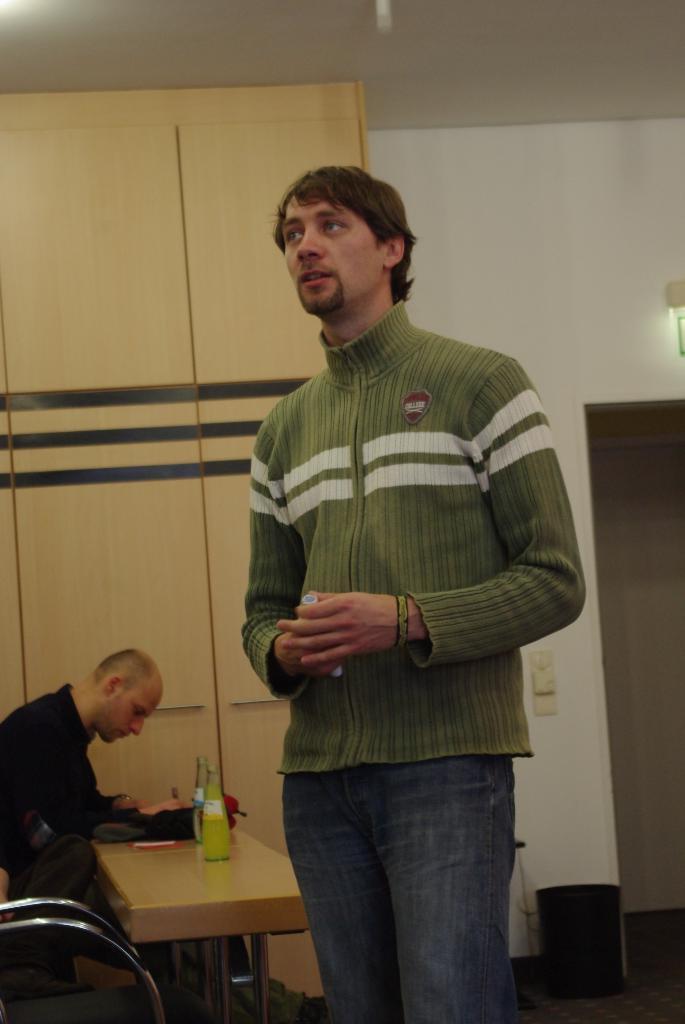Can you describe this image briefly? This is a picture taken in a room. The man in blue jacket was standing on the floor and the other man in black jacket was sitting on a chair in front of the man there is a table on top of the table there are bottles and paper. Behind the people there are cupboards and a wall. 